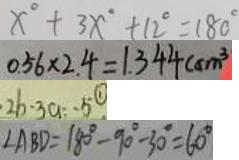<formula> <loc_0><loc_0><loc_500><loc_500>x ^ { \circ } + 3 x ^ { \circ } + 1 2 ^ { \circ } = 1 8 0 ^ { \circ } 
 0 . 5 6 \times 2 . 4 = 1 . 3 4 4 ( c m ^ { 3 } 
 2 b \cdot 3 a = - 5 \textcircled { 1 } 
 \angle A B D = 1 8 0 ^ { \circ } - 9 0 ^ { \circ } - 3 0 ^ { \circ } = 6 0 ^ { \circ }</formula> 